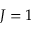<formula> <loc_0><loc_0><loc_500><loc_500>J = 1</formula> 